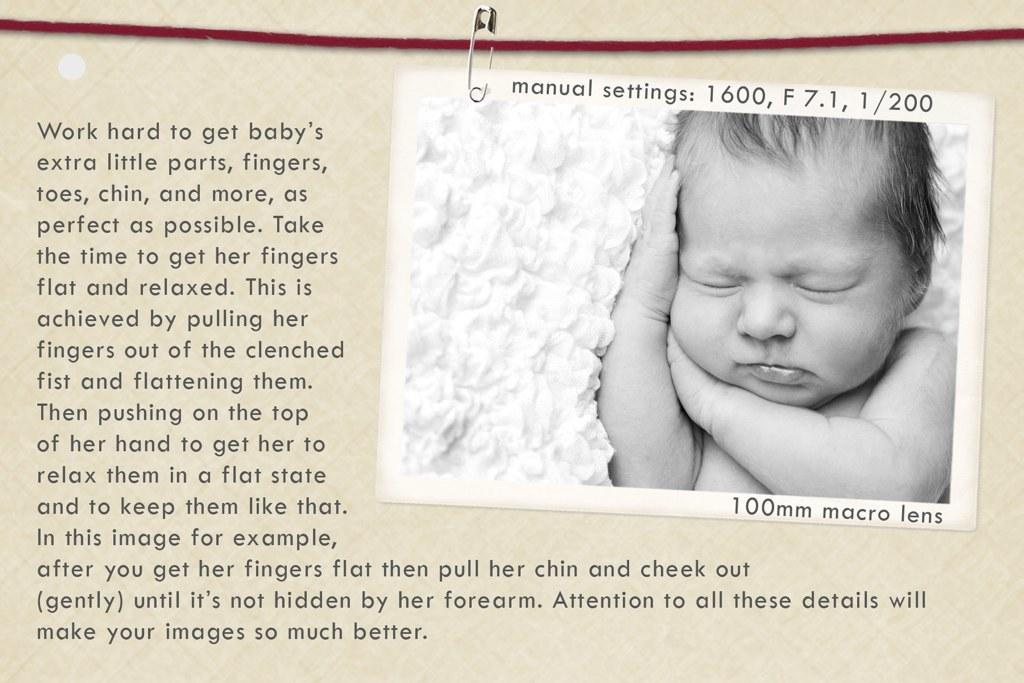What is the main subject of the paper in the image? The paper contains an image of a baby. Can you describe the content of the paper in more detail? The paper contains an image of a baby, but there is no additional information provided about the baby or the image. How many pigs are visible in the image? There are no pigs present in the image; it only contains a paper with an image of a baby. Is the baby in the image being held in a prison? There is no indication of a prison or any other context in the image; it only contains a paper with an image of a baby. 